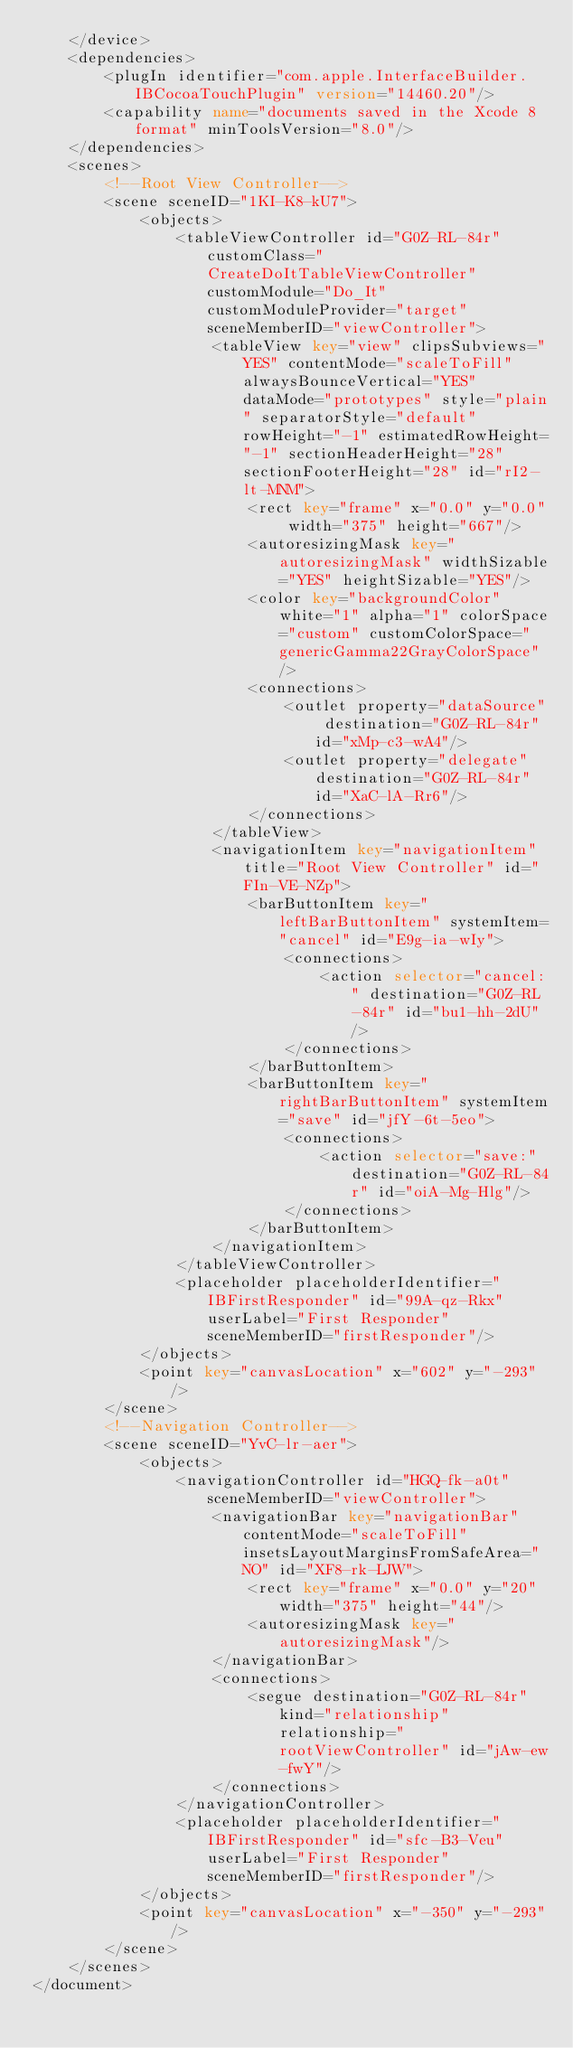Convert code to text. <code><loc_0><loc_0><loc_500><loc_500><_XML_>    </device>
    <dependencies>
        <plugIn identifier="com.apple.InterfaceBuilder.IBCocoaTouchPlugin" version="14460.20"/>
        <capability name="documents saved in the Xcode 8 format" minToolsVersion="8.0"/>
    </dependencies>
    <scenes>
        <!--Root View Controller-->
        <scene sceneID="1KI-K8-kU7">
            <objects>
                <tableViewController id="G0Z-RL-84r" customClass="CreateDoItTableViewController" customModule="Do_It" customModuleProvider="target" sceneMemberID="viewController">
                    <tableView key="view" clipsSubviews="YES" contentMode="scaleToFill" alwaysBounceVertical="YES" dataMode="prototypes" style="plain" separatorStyle="default" rowHeight="-1" estimatedRowHeight="-1" sectionHeaderHeight="28" sectionFooterHeight="28" id="rI2-lt-MNM">
                        <rect key="frame" x="0.0" y="0.0" width="375" height="667"/>
                        <autoresizingMask key="autoresizingMask" widthSizable="YES" heightSizable="YES"/>
                        <color key="backgroundColor" white="1" alpha="1" colorSpace="custom" customColorSpace="genericGamma22GrayColorSpace"/>
                        <connections>
                            <outlet property="dataSource" destination="G0Z-RL-84r" id="xMp-c3-wA4"/>
                            <outlet property="delegate" destination="G0Z-RL-84r" id="XaC-lA-Rr6"/>
                        </connections>
                    </tableView>
                    <navigationItem key="navigationItem" title="Root View Controller" id="FIn-VE-NZp">
                        <barButtonItem key="leftBarButtonItem" systemItem="cancel" id="E9g-ia-wIy">
                            <connections>
                                <action selector="cancel:" destination="G0Z-RL-84r" id="bu1-hh-2dU"/>
                            </connections>
                        </barButtonItem>
                        <barButtonItem key="rightBarButtonItem" systemItem="save" id="jfY-6t-5eo">
                            <connections>
                                <action selector="save:" destination="G0Z-RL-84r" id="oiA-Mg-Hlg"/>
                            </connections>
                        </barButtonItem>
                    </navigationItem>
                </tableViewController>
                <placeholder placeholderIdentifier="IBFirstResponder" id="99A-qz-Rkx" userLabel="First Responder" sceneMemberID="firstResponder"/>
            </objects>
            <point key="canvasLocation" x="602" y="-293"/>
        </scene>
        <!--Navigation Controller-->
        <scene sceneID="YvC-lr-aer">
            <objects>
                <navigationController id="HGQ-fk-a0t" sceneMemberID="viewController">
                    <navigationBar key="navigationBar" contentMode="scaleToFill" insetsLayoutMarginsFromSafeArea="NO" id="XF8-rk-LJW">
                        <rect key="frame" x="0.0" y="20" width="375" height="44"/>
                        <autoresizingMask key="autoresizingMask"/>
                    </navigationBar>
                    <connections>
                        <segue destination="G0Z-RL-84r" kind="relationship" relationship="rootViewController" id="jAw-ew-fwY"/>
                    </connections>
                </navigationController>
                <placeholder placeholderIdentifier="IBFirstResponder" id="sfc-B3-Veu" userLabel="First Responder" sceneMemberID="firstResponder"/>
            </objects>
            <point key="canvasLocation" x="-350" y="-293"/>
        </scene>
    </scenes>
</document>
</code> 